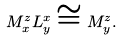<formula> <loc_0><loc_0><loc_500><loc_500>M ^ { z } _ { x } L ^ { x } _ { y } \cong M ^ { z } _ { y } .</formula> 